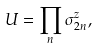Convert formula to latex. <formula><loc_0><loc_0><loc_500><loc_500>U = \prod _ { n } { \sigma } _ { 2 n } ^ { z } ,</formula> 